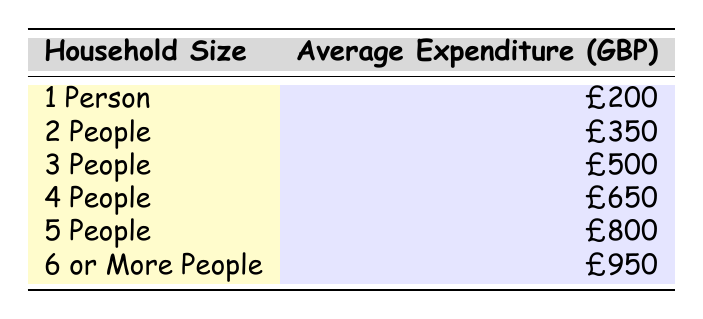What's the average monthly grocery expenditure for a household of 1 person? The table indicates that the average expenditure for a household size of 1 person is 200 GBP.
Answer: 200 GBP What is the average grocery expenditure for a household of 4 people? According to the table, the average monthly expenditure for 4 people is shown as 650 GBP.
Answer: 650 GBP How much more does a household of 6 or more people spend on groceries compared to a household of 2 people? The average expenditure for a household of 6 or more people is 950 GBP, while for a household of 2 people, it is 350 GBP. The difference is 950 - 350 = 600 GBP.
Answer: 600 GBP Is the average expenditure for a household with 3 people greater than that of a household with 1 person? The average expenditure for 3 people is 500 GBP, while for 1 person it is 200 GBP. Since 500 is greater than 200, the statement is true.
Answer: Yes What is the total average monthly grocery expenditure for all household sizes combined? To find the total, we sum the values: 200 + 350 + 500 + 650 + 800 + 950 = 3450 GBP.
Answer: 3450 GBP How much does a household of 5 people spend less than a household of 6 or more people? A household of 5 people spends 800 GBP, and a household of 6 or more people spends 950 GBP. The difference is 950 - 800 = 150 GBP.
Answer: 150 GBP Is it true that a household of 4 people spends exactly 50% more than a household of 2 people? The average expenditure for 4 people is 650 GBP, and for 2 people, it is 350 GBP. To check: 50% of 350 is 175, thus 350 + 175 = 525. Since 650 is greater than 525, the statement is false.
Answer: No What is the average expenditure for a household of 3 people compared to a household of 5 people? The average expenditure for a household of 3 people is 500 GBP, and for 5 people, it is 800 GBP. Therefore, 800 - 500 = 300 GBP more for 5 people.
Answer: 300 GBP more How much more does the average household size of 6 or more people spend than the average for all households with fewer than 6 people? First, we calculate the average for households with fewer than 6 people: (200 + 350 + 500 + 650 + 800) / 5 = 510 GBP. The difference with 950 GBP for 6 or more is 950 - 510 = 440 GBP.
Answer: 440 GBP 